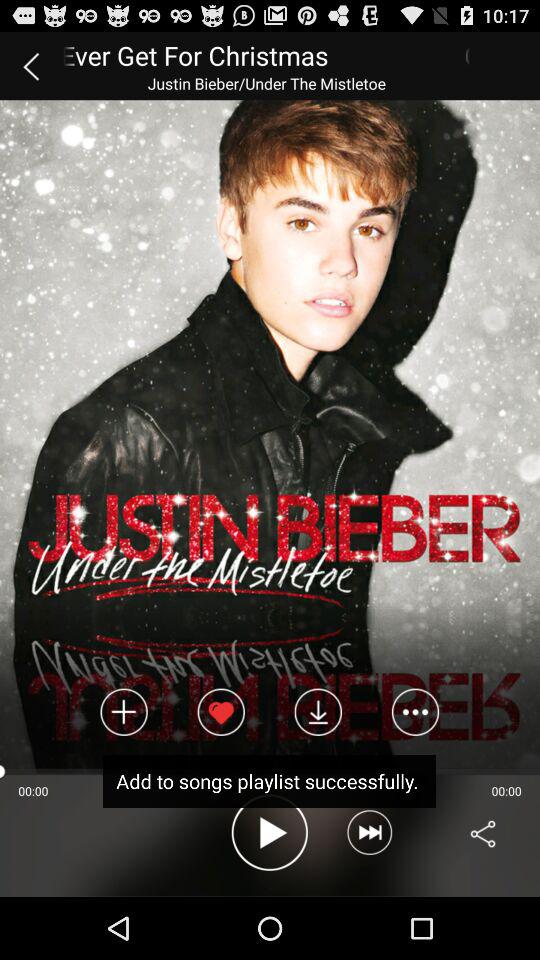What is the song's name? The song's name is "Ever Get For Christmas". 